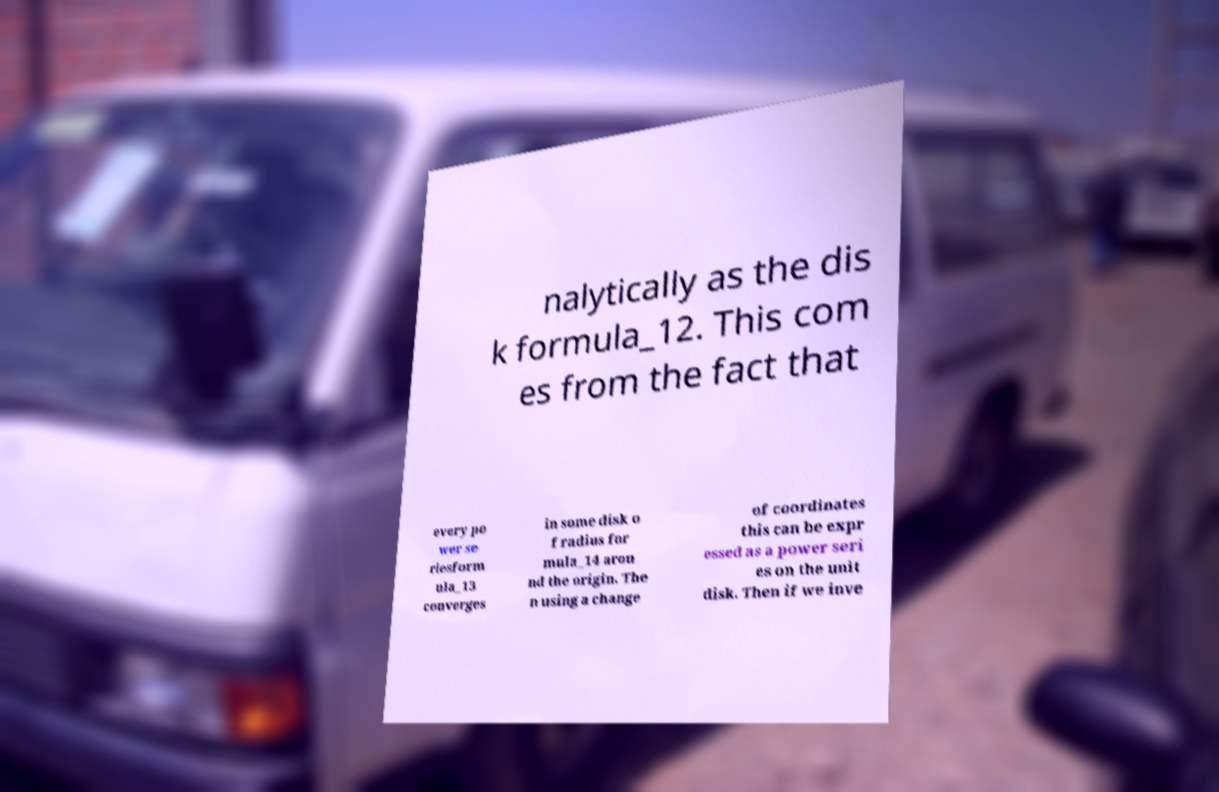For documentation purposes, I need the text within this image transcribed. Could you provide that? nalytically as the dis k formula_12. This com es from the fact that every po wer se riesform ula_13 converges in some disk o f radius for mula_14 arou nd the origin. The n using a change of coordinates this can be expr essed as a power seri es on the unit disk. Then if we inve 